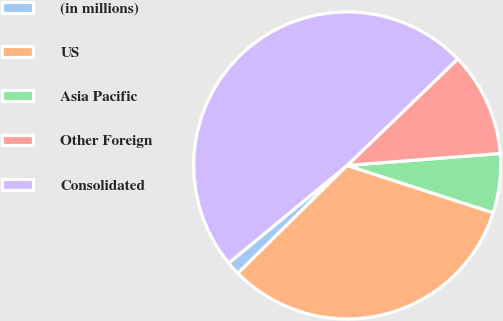<chart> <loc_0><loc_0><loc_500><loc_500><pie_chart><fcel>(in millions)<fcel>US<fcel>Asia Pacific<fcel>Other Foreign<fcel>Consolidated<nl><fcel>1.43%<fcel>32.62%<fcel>6.23%<fcel>10.97%<fcel>48.76%<nl></chart> 